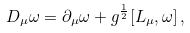Convert formula to latex. <formula><loc_0><loc_0><loc_500><loc_500>D _ { \mu } \omega = \partial _ { \mu } \omega + g ^ { \frac { 1 } { 2 } } [ L _ { \mu } , \omega ] \, ,</formula> 